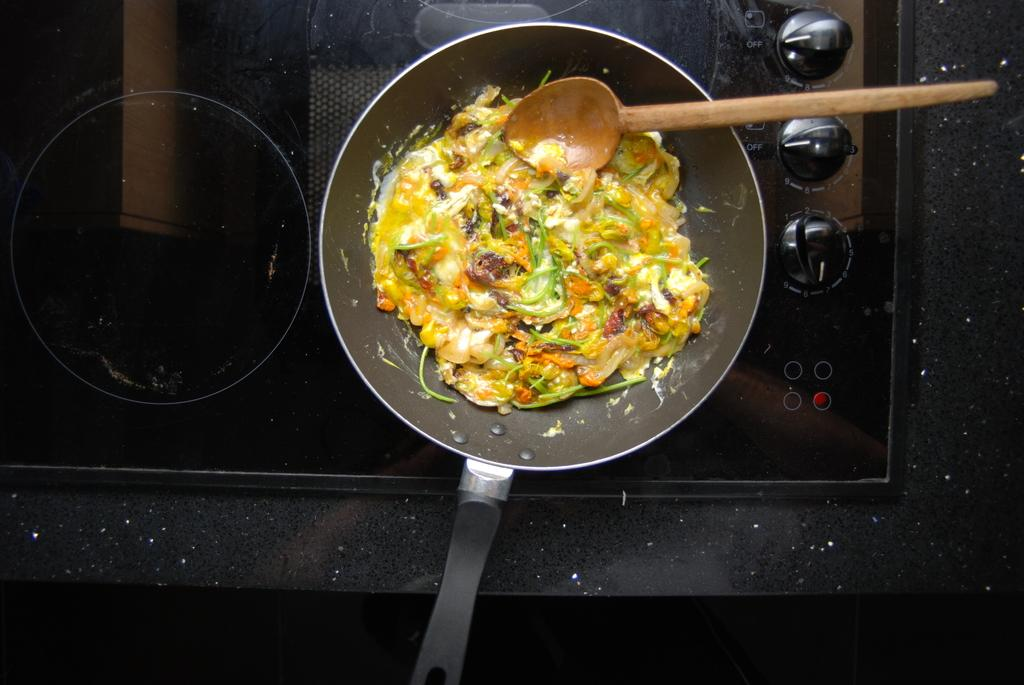What is being cooked in the pan in the image? There is a food item in a pan in the image. What utensil is being used to stir the food in the pan? There is a spoon in the pan. Where is the pan located in the image? The pan is on top of a stove. What material is the platform that the stove is on made of? The stove is on a marble platform. What color crayon is being used to draw on the birthday cake in the image? There is no crayon or birthday cake present in the image. 